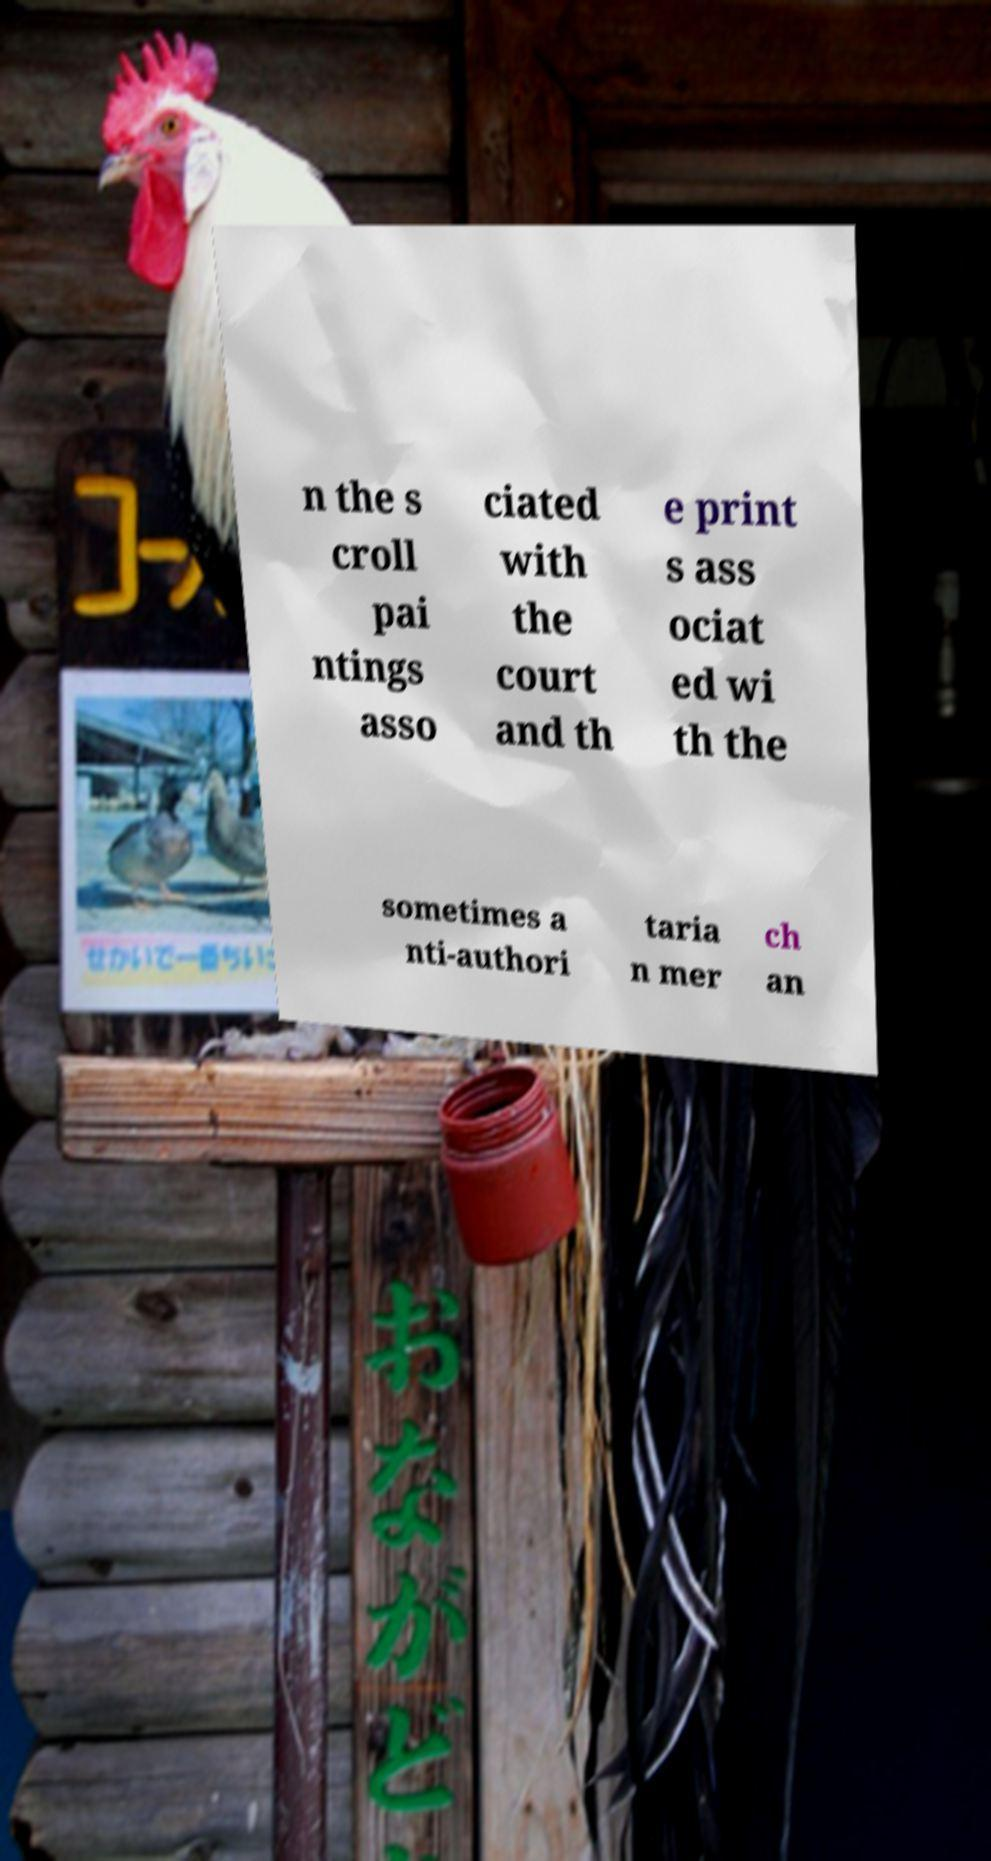I need the written content from this picture converted into text. Can you do that? n the s croll pai ntings asso ciated with the court and th e print s ass ociat ed wi th the sometimes a nti-authori taria n mer ch an 